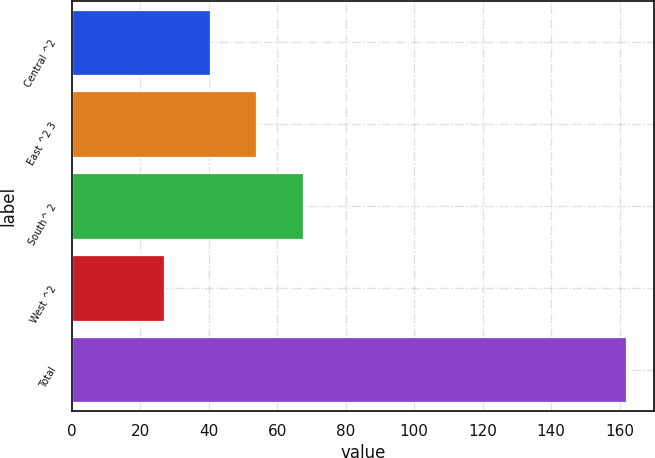<chart> <loc_0><loc_0><loc_500><loc_500><bar_chart><fcel>Central ^2<fcel>East ^2 3<fcel>South^ 2<fcel>West ^2<fcel>Total<nl><fcel>40.49<fcel>53.98<fcel>67.47<fcel>27<fcel>161.9<nl></chart> 